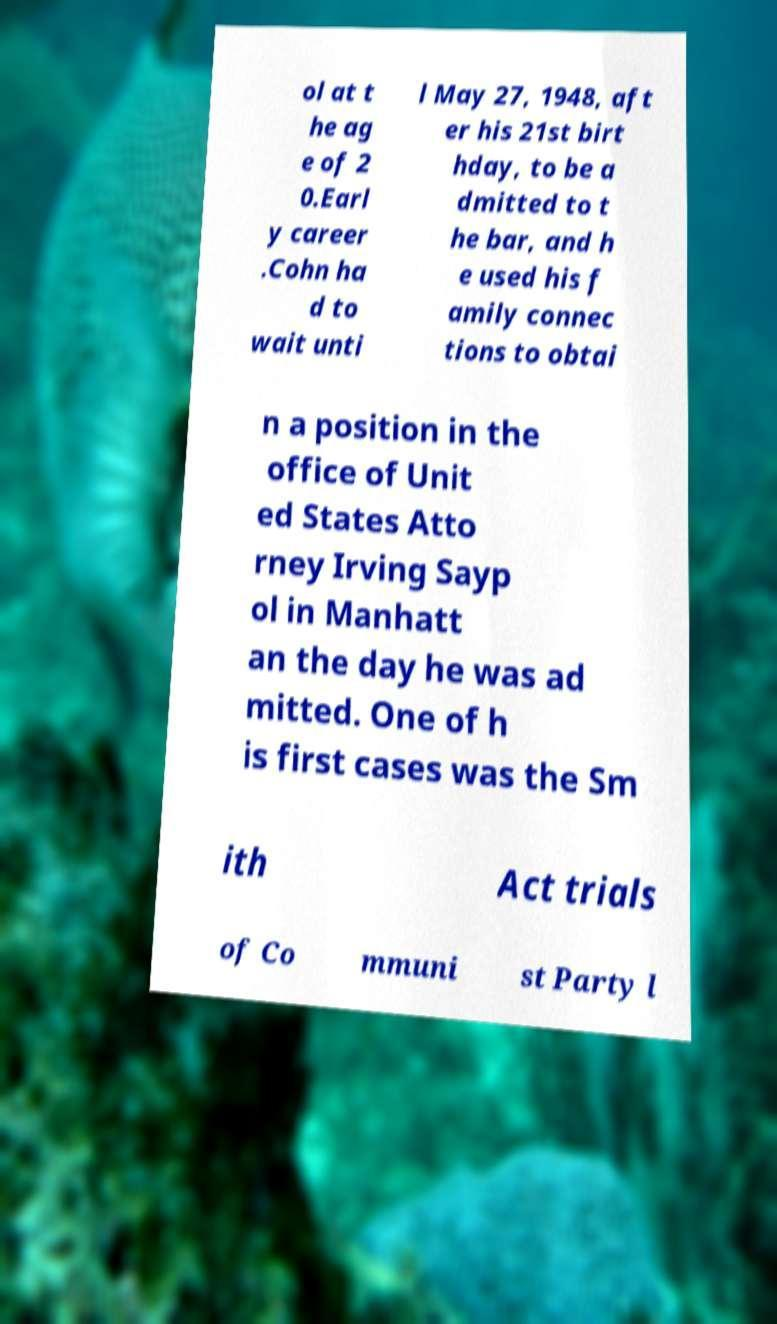I need the written content from this picture converted into text. Can you do that? ol at t he ag e of 2 0.Earl y career .Cohn ha d to wait unti l May 27, 1948, aft er his 21st birt hday, to be a dmitted to t he bar, and h e used his f amily connec tions to obtai n a position in the office of Unit ed States Atto rney Irving Sayp ol in Manhatt an the day he was ad mitted. One of h is first cases was the Sm ith Act trials of Co mmuni st Party l 